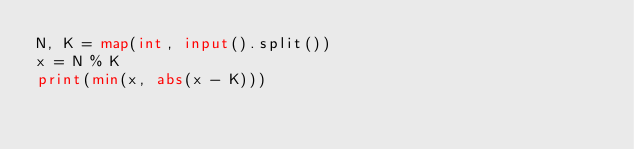<code> <loc_0><loc_0><loc_500><loc_500><_Python_>N, K = map(int, input().split())
x = N % K
print(min(x, abs(x - K)))</code> 